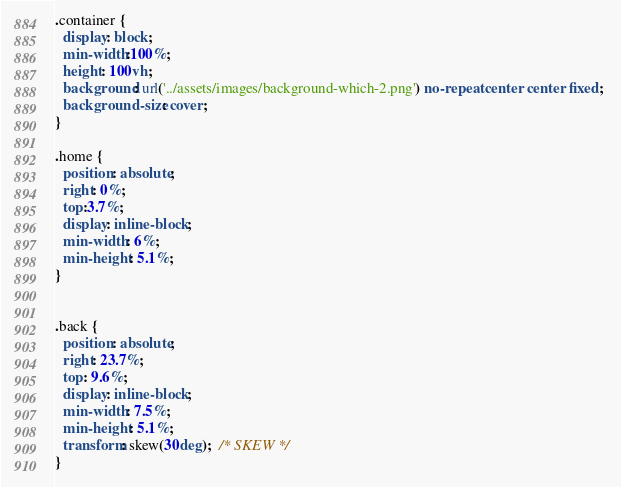Convert code to text. <code><loc_0><loc_0><loc_500><loc_500><_CSS_>.container {
  display: block;
  min-width:100%;
  height: 100vh;
  background: url('../assets/images/background-which-2.png') no-repeat center center fixed; 
  background-size: cover;
}

.home {
  position: absolute;
  right: 0%;
  top:3.7%;
  display: inline-block;
  min-width: 6%;
  min-height: 5.1%;
}


.back {
  position: absolute;
  right: 23.7%;
  top: 9.6%;
  display: inline-block;
  min-width: 7.5%;
  min-height: 5.1%;
  transform: skew(30deg);  /* SKEW */
}
</code> 